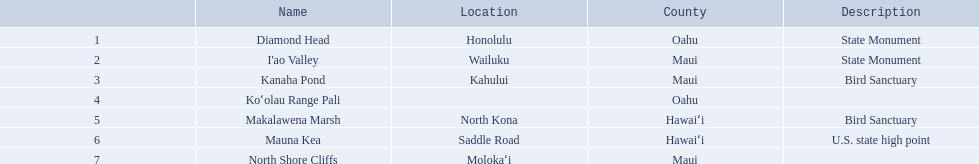What are the natural landmarks in hawaii(national)? Diamond Head, I'ao Valley, Kanaha Pond, Koʻolau Range Pali, Makalawena Marsh, Mauna Kea, North Shore Cliffs. Of these which is described as a u.s state high point? Mauna Kea. 